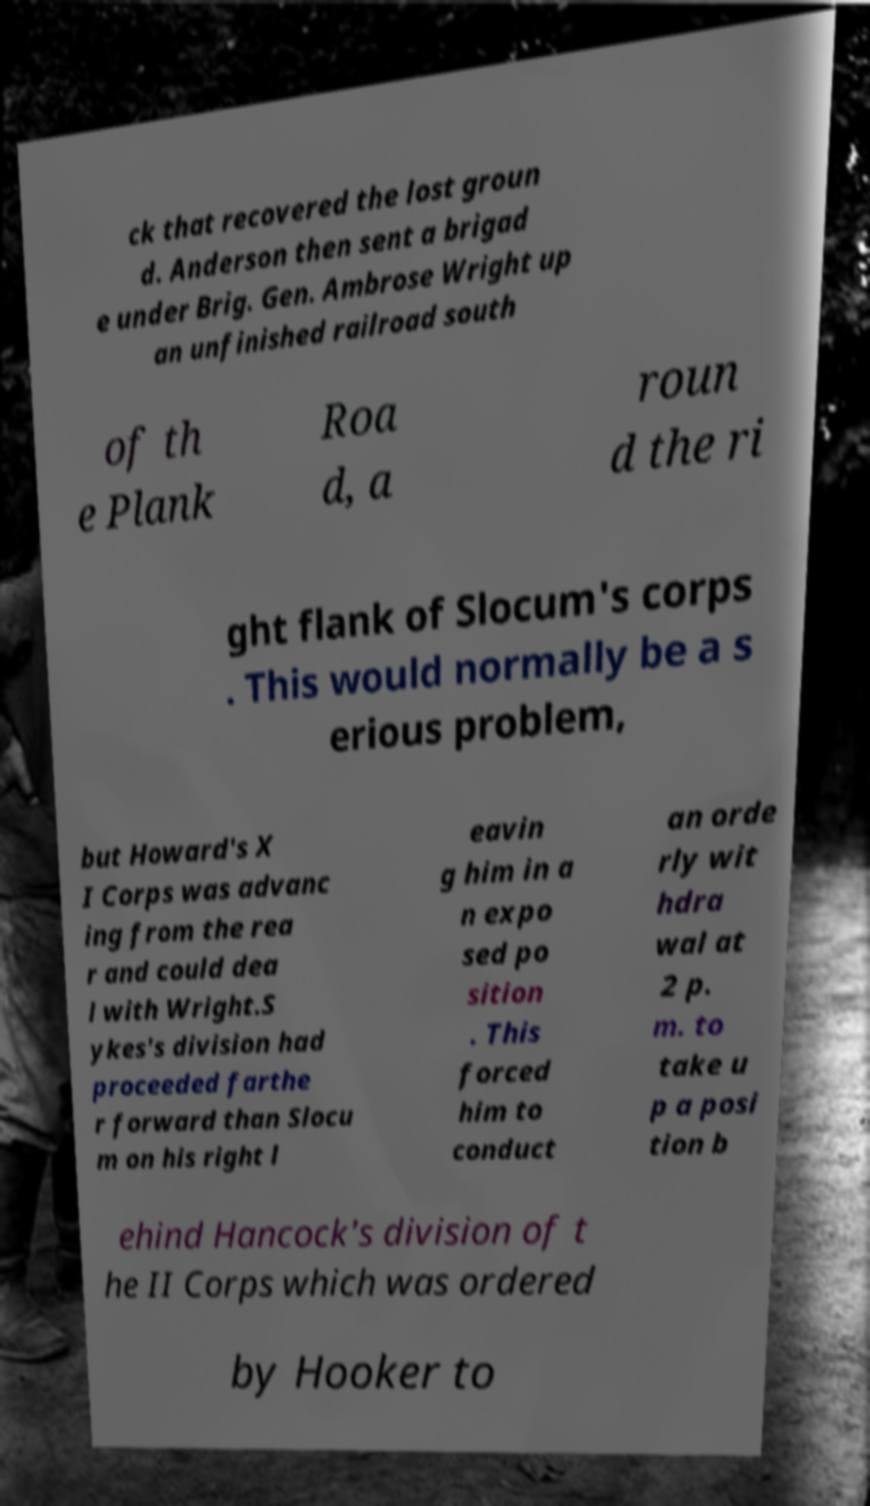Please identify and transcribe the text found in this image. ck that recovered the lost groun d. Anderson then sent a brigad e under Brig. Gen. Ambrose Wright up an unfinished railroad south of th e Plank Roa d, a roun d the ri ght flank of Slocum's corps . This would normally be a s erious problem, but Howard's X I Corps was advanc ing from the rea r and could dea l with Wright.S ykes's division had proceeded farthe r forward than Slocu m on his right l eavin g him in a n expo sed po sition . This forced him to conduct an orde rly wit hdra wal at 2 p. m. to take u p a posi tion b ehind Hancock's division of t he II Corps which was ordered by Hooker to 